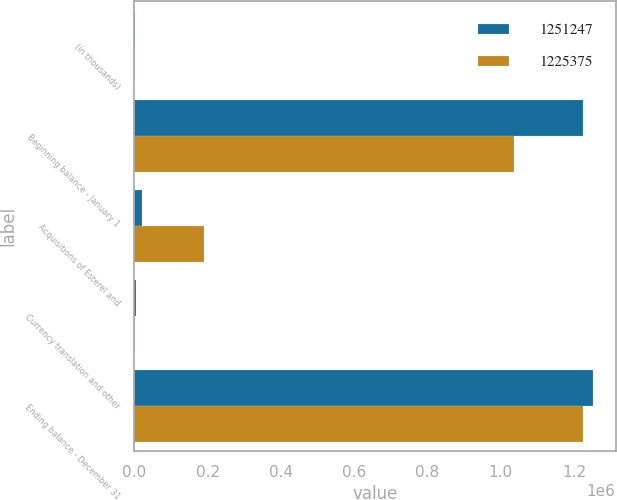<chart> <loc_0><loc_0><loc_500><loc_500><stacked_bar_chart><ecel><fcel>(in thousands)<fcel>Beginning balance - January 1<fcel>Acquisitions of Esterel and<fcel>Currency translation and other<fcel>Ending balance - December 31<nl><fcel>1.25125e+06<fcel>2012<fcel>1.22538e+06<fcel>20866<fcel>5006<fcel>1.25125e+06<nl><fcel>1.22538e+06<fcel>2011<fcel>1.03508e+06<fcel>190947<fcel>655<fcel>1.22538e+06<nl></chart> 